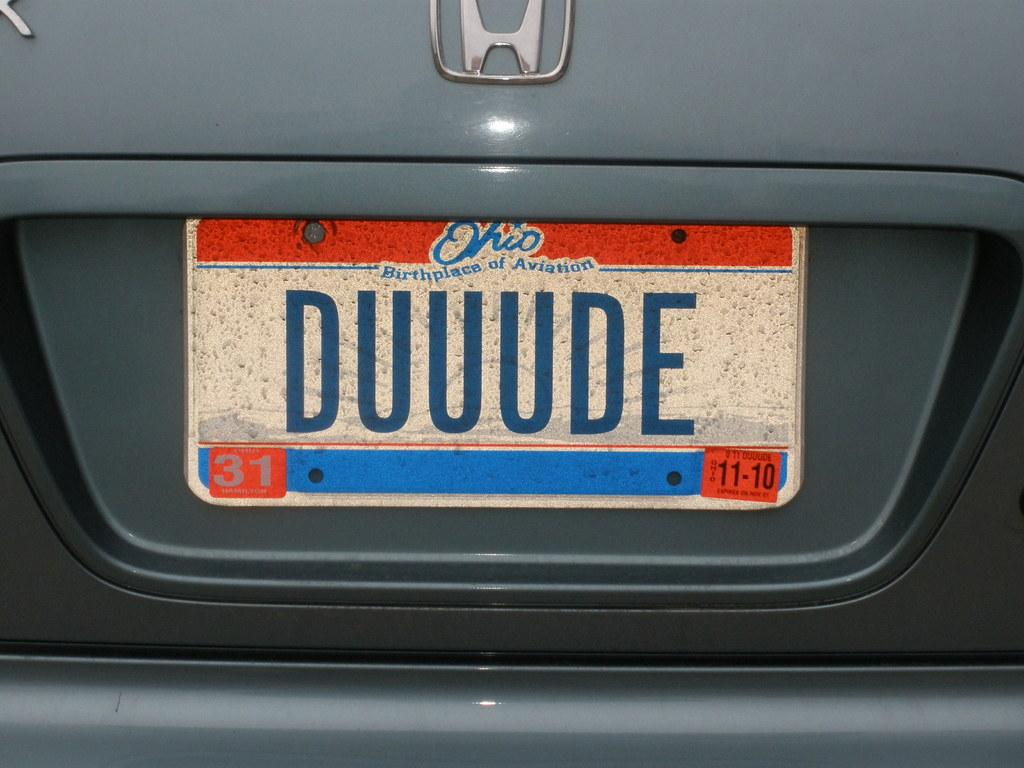<image>
Share a concise interpretation of the image provided. A license plate for the state of Ohio that has the number 31 on it. 